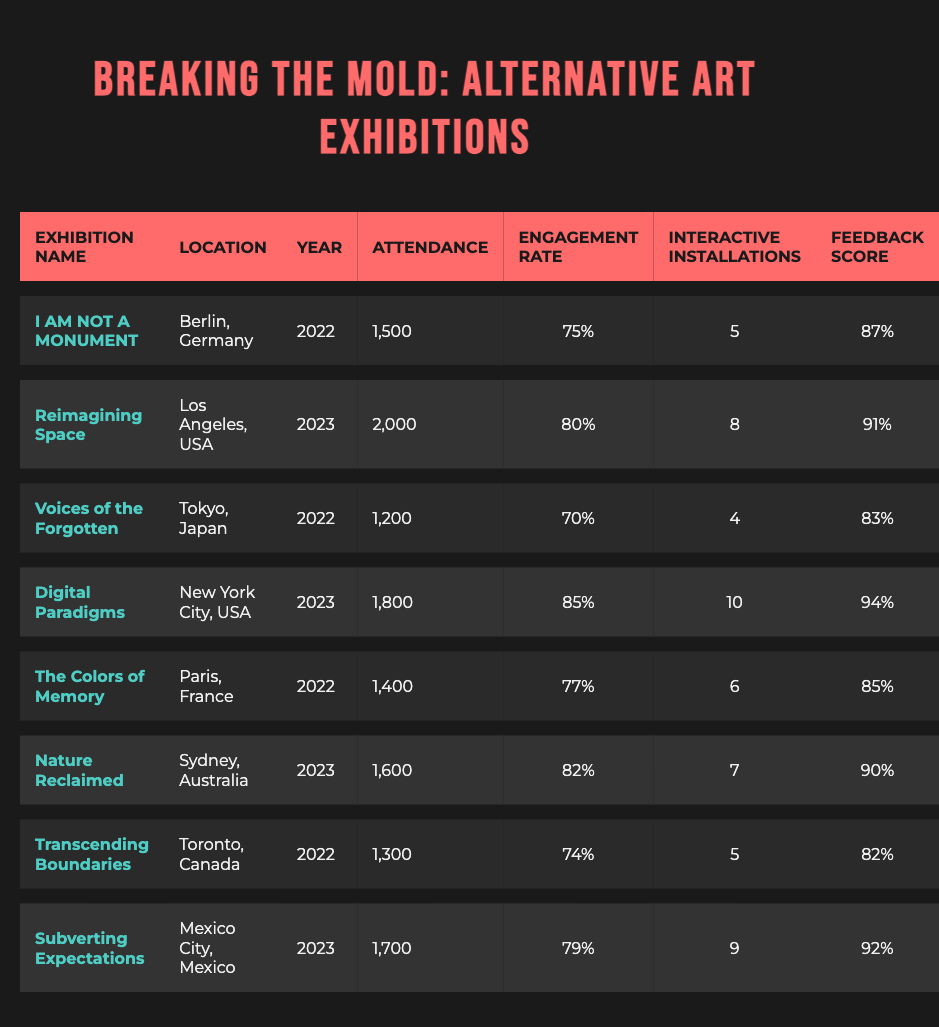What was the highest attendance at an exhibition in 2023? The exhibitions in 2023 were "Reimagining Space" (2000), "Digital Paradigms" (1800), "Nature Reclaimed" (1600), and "Subverting Expectations" (1700). The highest attendance among these is 2000 by "Reimagining Space".
Answer: 2000 Which exhibition had the lowest feedback score in 2022? The exhibitions in 2022 were: "I AM NOT A MONUMENT" (8.7), "Voices of the Forgotten" (8.3), "The Colors of Memory" (8.5), and "Transcending Boundaries" (8.2). The lowest feedback score among these is 8.2 by "Transcending Boundaries".
Answer: 8.2 Was the engagement rate higher in 2023 compared to 2022 for all exhibitions? In 2022, the engagement rates were: 75%, 70%, 77%, and 74%. In 2023, they were: 80%, 85%, 82%, and 79%. Since all values in 2023 are higher, the answer is yes.
Answer: Yes What is the average engagement rate across all exhibitions? The engagement rates are 75%, 80%, 70%, 85%, 77%, 82%, 74%, and 79%. Summing these gives 625%, and dividing by 8 exhibitions results in an average of 78.125%.
Answer: 78.1 Which exhibition had the most interactive installations in 2022? The exhibitions in 2022 are: "I AM NOT A MONUMENT" (5), "Voices of the Forgotten" (4), "The Colors of Memory" (6), and "Transcending Boundaries" (5). The highest is 6 by "The Colors of Memory".
Answer: 6 What is the total attendance for exhibitions held in Sydney and Los Angeles? The attendance for "Reimagining Space" (2000) in Los Angeles and "Nature Reclaimed" (1600) in Sydney adds up to 3600.
Answer: 3600 Was "Digital Paradigms" more popular than "Nature Reclaimed" based on attendance? "Digital Paradigms" had an attendance of 1800 while "Nature Reclaimed" had 1600. Since 1800 is greater than 1600, "Digital Paradigms" was more popular.
Answer: Yes How many interactive installations were there in total across all exhibitions? The total number of interactive installations are 5, 8, 4, 10, 6, 7, 5, and 9, which adds up to 54 installations.
Answer: 54 Which location hosted the highest engagement rate exhibition in 2023? "Digital Paradigms" had the highest engagement rate of 85% in New York City, making it the top engagement exhibition for 2023.
Answer: New York City 